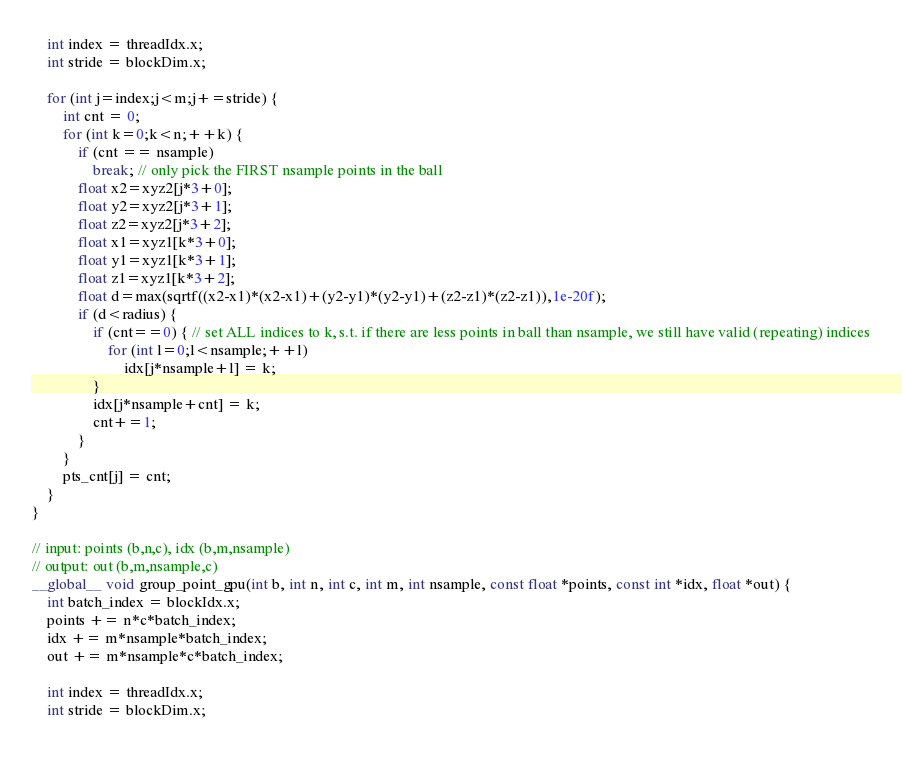Convert code to text. <code><loc_0><loc_0><loc_500><loc_500><_Cuda_>
    int index = threadIdx.x;
    int stride = blockDim.x;
    
    for (int j=index;j<m;j+=stride) {
        int cnt = 0;
        for (int k=0;k<n;++k) {
            if (cnt == nsample)
                break; // only pick the FIRST nsample points in the ball
            float x2=xyz2[j*3+0];
            float y2=xyz2[j*3+1];
            float z2=xyz2[j*3+2];
            float x1=xyz1[k*3+0];
            float y1=xyz1[k*3+1];
            float z1=xyz1[k*3+2];
    	    float d=max(sqrtf((x2-x1)*(x2-x1)+(y2-y1)*(y2-y1)+(z2-z1)*(z2-z1)),1e-20f);
            if (d<radius) {
                if (cnt==0) { // set ALL indices to k, s.t. if there are less points in ball than nsample, we still have valid (repeating) indices
                    for (int l=0;l<nsample;++l)
                        idx[j*nsample+l] = k;
                }
                idx[j*nsample+cnt] = k;
                cnt+=1;
            }
        }
        pts_cnt[j] = cnt;
    }
}

// input: points (b,n,c), idx (b,m,nsample)
// output: out (b,m,nsample,c)
__global__ void group_point_gpu(int b, int n, int c, int m, int nsample, const float *points, const int *idx, float *out) {
    int batch_index = blockIdx.x;
    points += n*c*batch_index;
    idx += m*nsample*batch_index;
    out += m*nsample*c*batch_index;

    int index = threadIdx.x;
    int stride = blockDim.x;
    </code> 